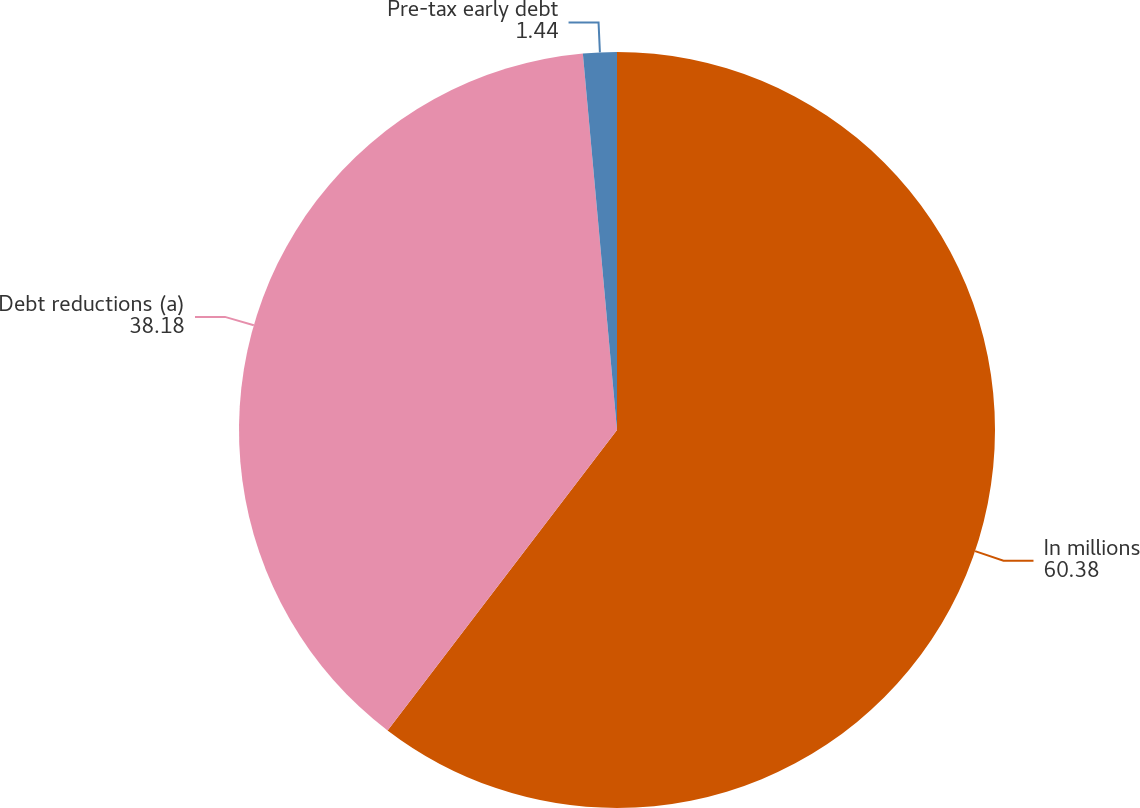Convert chart. <chart><loc_0><loc_0><loc_500><loc_500><pie_chart><fcel>In millions<fcel>Debt reductions (a)<fcel>Pre-tax early debt<nl><fcel>60.38%<fcel>38.18%<fcel>1.44%<nl></chart> 